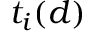<formula> <loc_0><loc_0><loc_500><loc_500>t _ { i } ( d )</formula> 